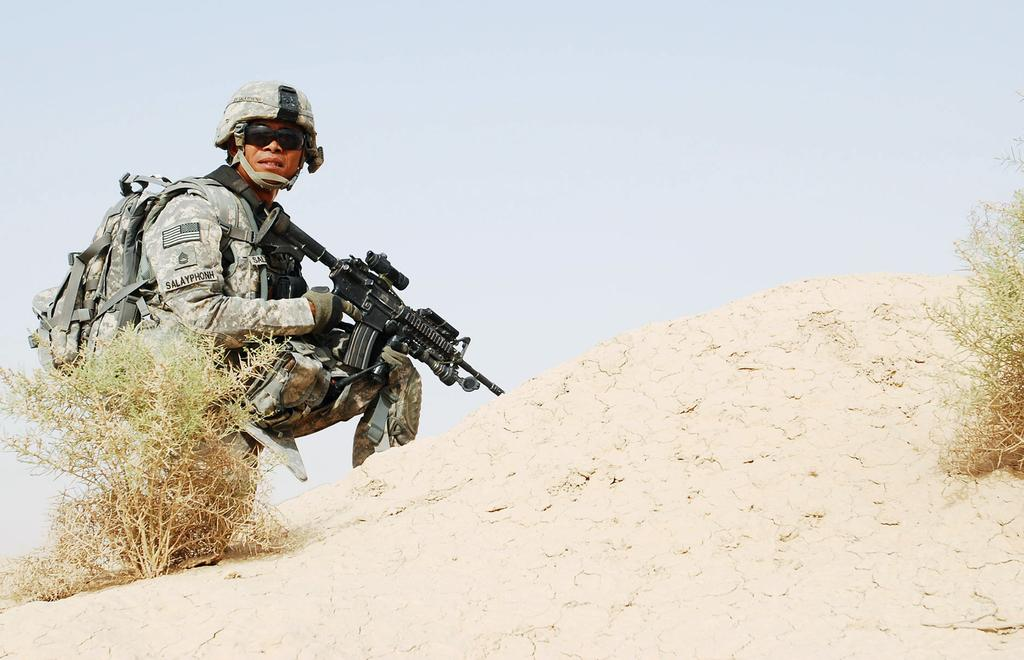What is the man on the left side of the image wearing? The man is wearing an army dress. What type of headgear is the man wearing? The man is wearing a cap. What is the man holding in his hands? The man is holding a weapon. What can be seen in the background of the image? There are trees on either side of the image. What type of pot is being exchanged between the trees in the image? There is no pot or exchange taking place between the trees in the image; it only features a man in army dress holding a weapon. 